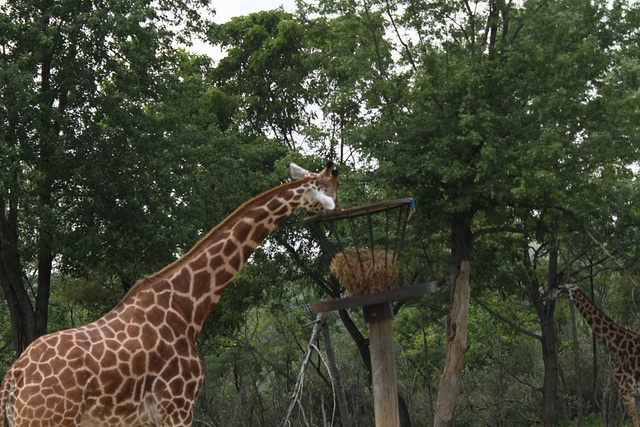Describe the objects in this image and their specific colors. I can see giraffe in white, maroon, gray, and black tones and giraffe in white, black, and gray tones in this image. 